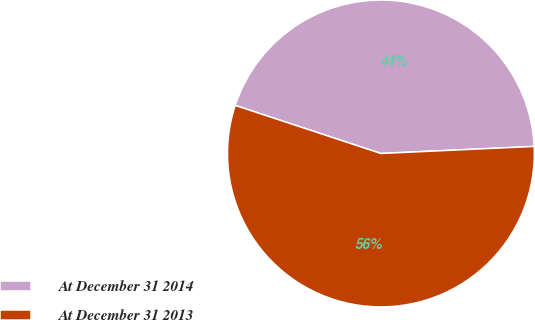Convert chart to OTSL. <chart><loc_0><loc_0><loc_500><loc_500><pie_chart><fcel>At December 31 2014<fcel>At December 31 2013<nl><fcel>44.2%<fcel>55.8%<nl></chart> 